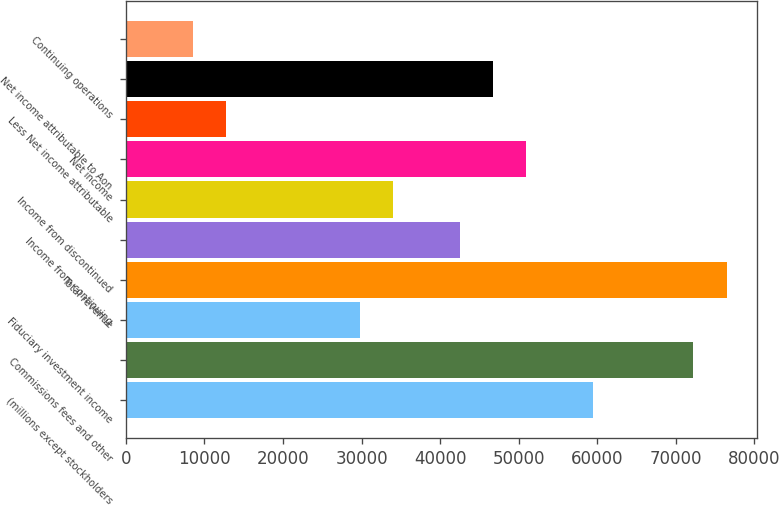Convert chart. <chart><loc_0><loc_0><loc_500><loc_500><bar_chart><fcel>(millions except stockholders<fcel>Commissions fees and other<fcel>Fiduciary investment income<fcel>Total revenue<fcel>Income from continuing<fcel>Income from discontinued<fcel>Net income<fcel>Less Net income attributable<fcel>Net income attributable to Aon<fcel>Continuing operations<nl><fcel>59499.8<fcel>72249.6<fcel>29750.2<fcel>76499.5<fcel>42500<fcel>34000.1<fcel>50999.9<fcel>12750.4<fcel>46749.9<fcel>8500.48<nl></chart> 